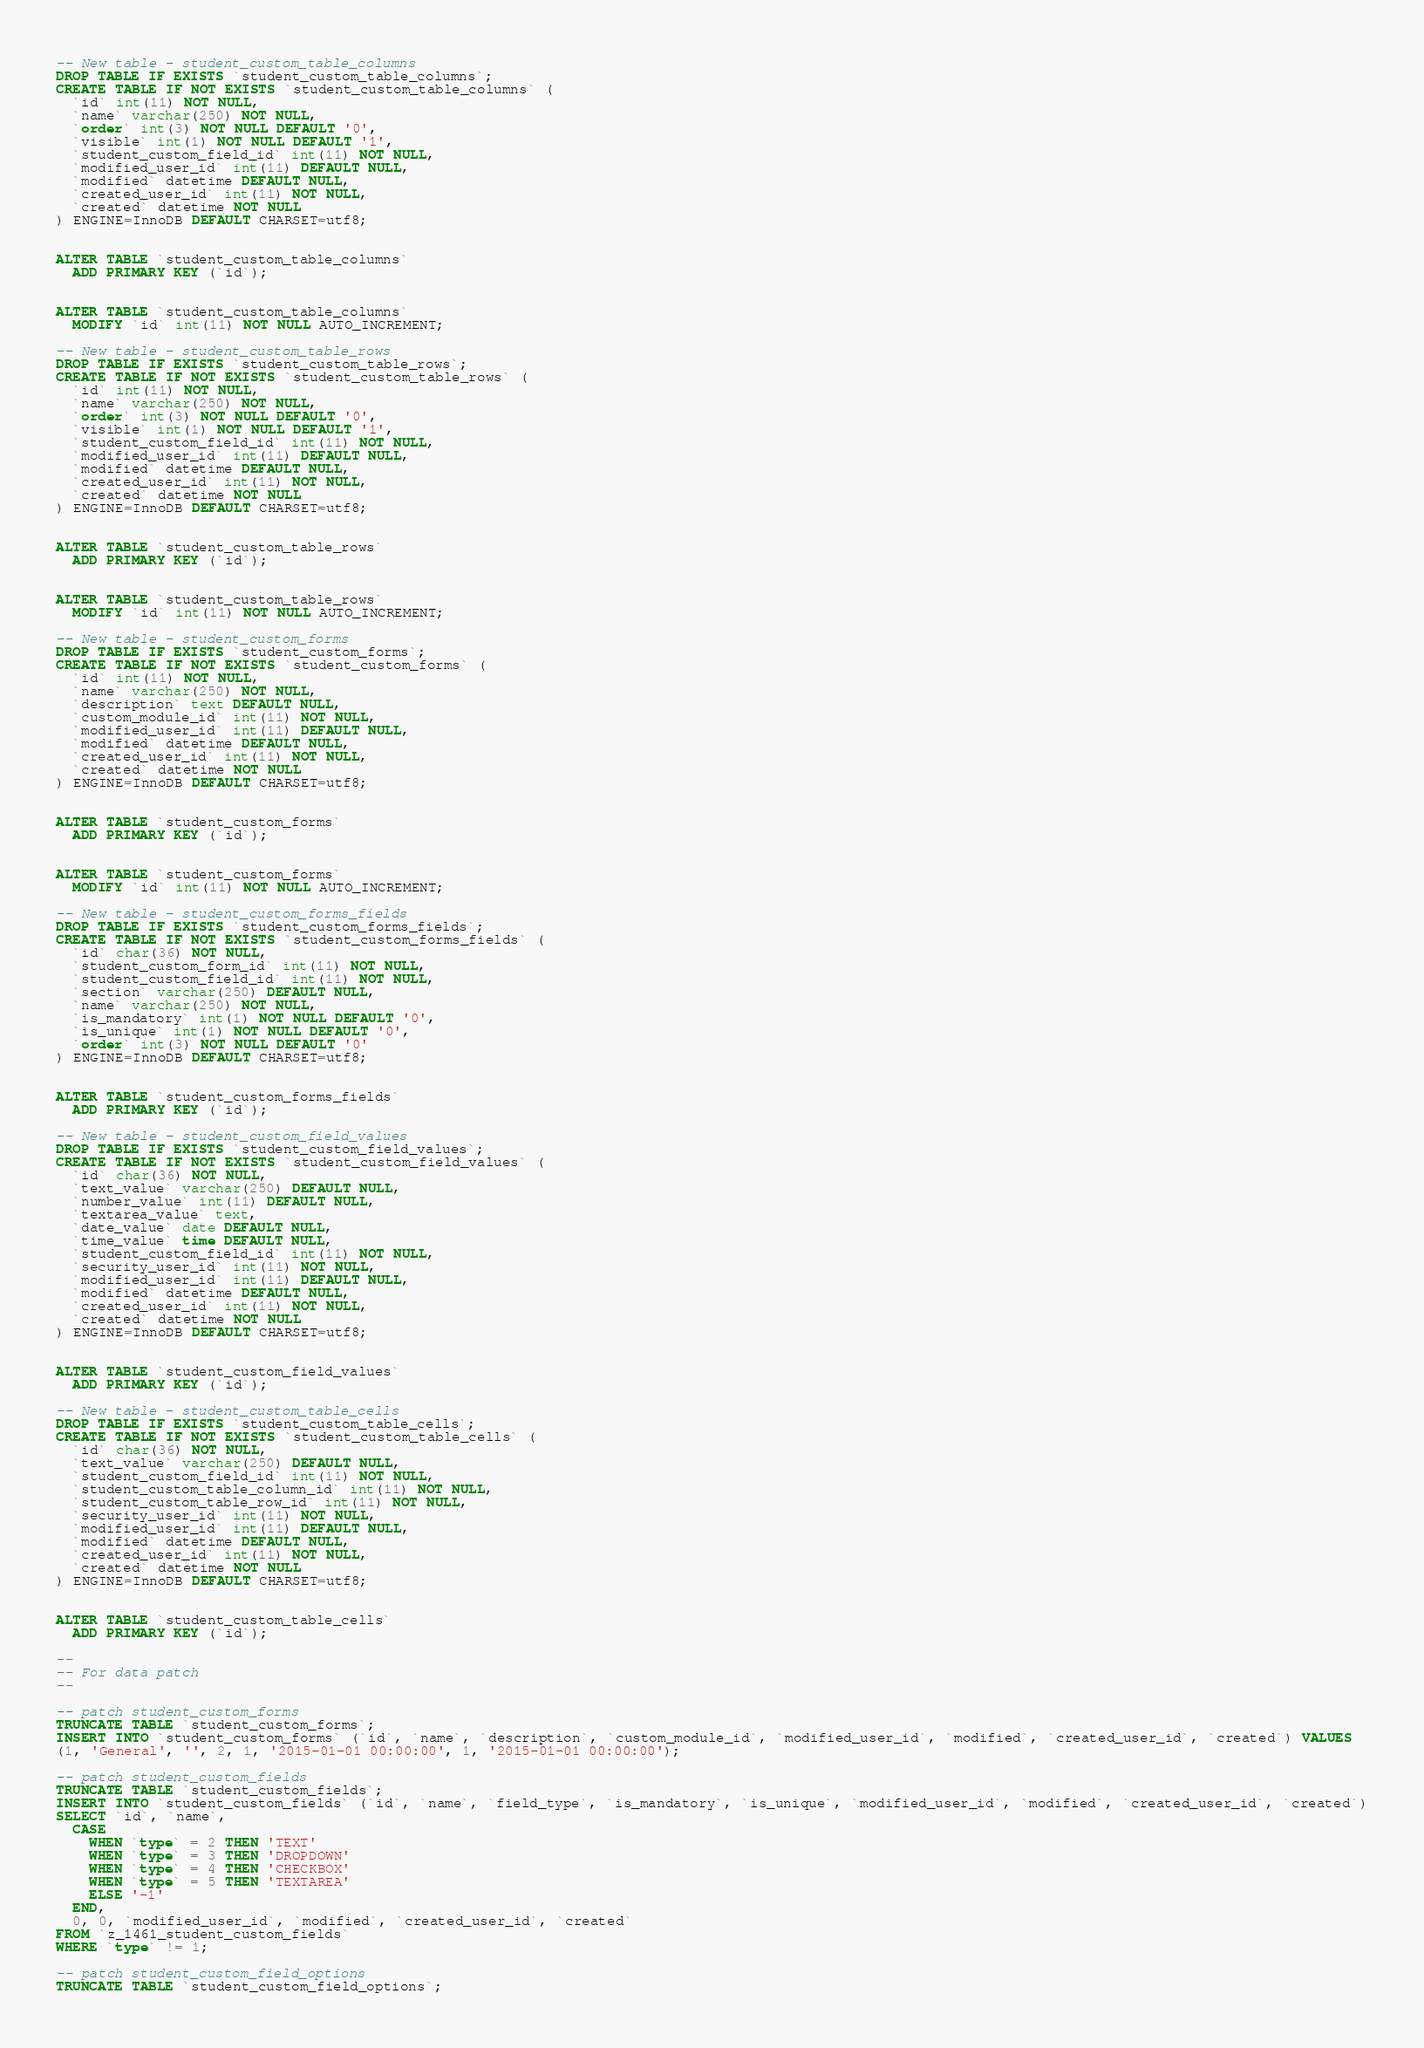Convert code to text. <code><loc_0><loc_0><loc_500><loc_500><_SQL_>
-- New table - student_custom_table_columns
DROP TABLE IF EXISTS `student_custom_table_columns`;
CREATE TABLE IF NOT EXISTS `student_custom_table_columns` (
  `id` int(11) NOT NULL,
  `name` varchar(250) NOT NULL,
  `order` int(3) NOT NULL DEFAULT '0',
  `visible` int(1) NOT NULL DEFAULT '1',
  `student_custom_field_id` int(11) NOT NULL,
  `modified_user_id` int(11) DEFAULT NULL,
  `modified` datetime DEFAULT NULL,
  `created_user_id` int(11) NOT NULL,
  `created` datetime NOT NULL
) ENGINE=InnoDB DEFAULT CHARSET=utf8;


ALTER TABLE `student_custom_table_columns`
  ADD PRIMARY KEY (`id`);


ALTER TABLE `student_custom_table_columns`
  MODIFY `id` int(11) NOT NULL AUTO_INCREMENT;

-- New table - student_custom_table_rows
DROP TABLE IF EXISTS `student_custom_table_rows`;
CREATE TABLE IF NOT EXISTS `student_custom_table_rows` (
  `id` int(11) NOT NULL,
  `name` varchar(250) NOT NULL,
  `order` int(3) NOT NULL DEFAULT '0',
  `visible` int(1) NOT NULL DEFAULT '1',
  `student_custom_field_id` int(11) NOT NULL,
  `modified_user_id` int(11) DEFAULT NULL,
  `modified` datetime DEFAULT NULL,
  `created_user_id` int(11) NOT NULL,
  `created` datetime NOT NULL
) ENGINE=InnoDB DEFAULT CHARSET=utf8;


ALTER TABLE `student_custom_table_rows`
  ADD PRIMARY KEY (`id`);


ALTER TABLE `student_custom_table_rows`
  MODIFY `id` int(11) NOT NULL AUTO_INCREMENT;

-- New table - student_custom_forms
DROP TABLE IF EXISTS `student_custom_forms`;
CREATE TABLE IF NOT EXISTS `student_custom_forms` (
  `id` int(11) NOT NULL,
  `name` varchar(250) NOT NULL,
  `description` text DEFAULT NULL,
  `custom_module_id` int(11) NOT NULL,
  `modified_user_id` int(11) DEFAULT NULL,
  `modified` datetime DEFAULT NULL,
  `created_user_id` int(11) NOT NULL,
  `created` datetime NOT NULL
) ENGINE=InnoDB DEFAULT CHARSET=utf8;


ALTER TABLE `student_custom_forms`
  ADD PRIMARY KEY (`id`);


ALTER TABLE `student_custom_forms`
  MODIFY `id` int(11) NOT NULL AUTO_INCREMENT;

-- New table - student_custom_forms_fields
DROP TABLE IF EXISTS `student_custom_forms_fields`;
CREATE TABLE IF NOT EXISTS `student_custom_forms_fields` (
  `id` char(36) NOT NULL,
  `student_custom_form_id` int(11) NOT NULL,
  `student_custom_field_id` int(11) NOT NULL,
  `section` varchar(250) DEFAULT NULL,
  `name` varchar(250) NOT NULL,
  `is_mandatory` int(1) NOT NULL DEFAULT '0',
  `is_unique` int(1) NOT NULL DEFAULT '0',
  `order` int(3) NOT NULL DEFAULT '0'
) ENGINE=InnoDB DEFAULT CHARSET=utf8;


ALTER TABLE `student_custom_forms_fields`
  ADD PRIMARY KEY (`id`);

-- New table - student_custom_field_values
DROP TABLE IF EXISTS `student_custom_field_values`;
CREATE TABLE IF NOT EXISTS `student_custom_field_values` (
  `id` char(36) NOT NULL,
  `text_value` varchar(250) DEFAULT NULL,
  `number_value` int(11) DEFAULT NULL,
  `textarea_value` text,
  `date_value` date DEFAULT NULL,
  `time_value` time DEFAULT NULL,
  `student_custom_field_id` int(11) NOT NULL,
  `security_user_id` int(11) NOT NULL,
  `modified_user_id` int(11) DEFAULT NULL,
  `modified` datetime DEFAULT NULL,
  `created_user_id` int(11) NOT NULL,
  `created` datetime NOT NULL
) ENGINE=InnoDB DEFAULT CHARSET=utf8;


ALTER TABLE `student_custom_field_values`
  ADD PRIMARY KEY (`id`);

-- New table - student_custom_table_cells
DROP TABLE IF EXISTS `student_custom_table_cells`;
CREATE TABLE IF NOT EXISTS `student_custom_table_cells` (
  `id` char(36) NOT NULL,
  `text_value` varchar(250) DEFAULT NULL,
  `student_custom_field_id` int(11) NOT NULL,
  `student_custom_table_column_id` int(11) NOT NULL,
  `student_custom_table_row_id` int(11) NOT NULL,
  `security_user_id` int(11) NOT NULL,
  `modified_user_id` int(11) DEFAULT NULL,
  `modified` datetime DEFAULT NULL,
  `created_user_id` int(11) NOT NULL,
  `created` datetime NOT NULL
) ENGINE=InnoDB DEFAULT CHARSET=utf8;


ALTER TABLE `student_custom_table_cells`
  ADD PRIMARY KEY (`id`);

--
-- For data patch
--

-- patch student_custom_forms
TRUNCATE TABLE `student_custom_forms`;
INSERT INTO `student_custom_forms` (`id`, `name`, `description`, `custom_module_id`, `modified_user_id`, `modified`, `created_user_id`, `created`) VALUES
(1, 'General', '', 2, 1, '2015-01-01 00:00:00', 1, '2015-01-01 00:00:00');

-- patch student_custom_fields
TRUNCATE TABLE `student_custom_fields`;
INSERT INTO `student_custom_fields` (`id`, `name`, `field_type`, `is_mandatory`, `is_unique`, `modified_user_id`, `modified`, `created_user_id`, `created`)
SELECT `id`, `name`,
  CASE
    WHEN `type` = 2 THEN 'TEXT'
    WHEN `type` = 3 THEN 'DROPDOWN'
    WHEN `type` = 4 THEN 'CHECKBOX'
    WHEN `type` = 5 THEN 'TEXTAREA'
    ELSE '-1'
  END,
  0, 0, `modified_user_id`, `modified`, `created_user_id`, `created`
FROM `z_1461_student_custom_fields`
WHERE `type` != 1;

-- patch student_custom_field_options
TRUNCATE TABLE `student_custom_field_options`;</code> 